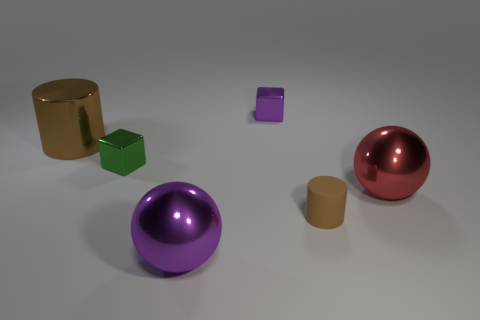What is the size of the metallic object that is the same shape as the small brown rubber object?
Ensure brevity in your answer.  Large. How many small cylinders have the same material as the red object?
Give a very brief answer. 0. There is a large cylinder; is it the same color as the small object that is behind the big brown shiny cylinder?
Provide a succinct answer. No. Is the number of purple spheres greater than the number of large blue metallic cylinders?
Give a very brief answer. Yes. What is the color of the rubber object?
Your answer should be very brief. Brown. There is a block that is in front of the large shiny cylinder; is its color the same as the metallic cylinder?
Make the answer very short. No. There is a big object that is the same color as the tiny rubber cylinder; what material is it?
Provide a short and direct response. Metal. How many cubes have the same color as the rubber cylinder?
Your answer should be very brief. 0. Do the brown thing that is on the left side of the small purple metallic cube and the green thing have the same shape?
Offer a terse response. No. Are there fewer big metal cylinders on the left side of the brown metal thing than red things to the left of the matte object?
Your answer should be compact. No. 